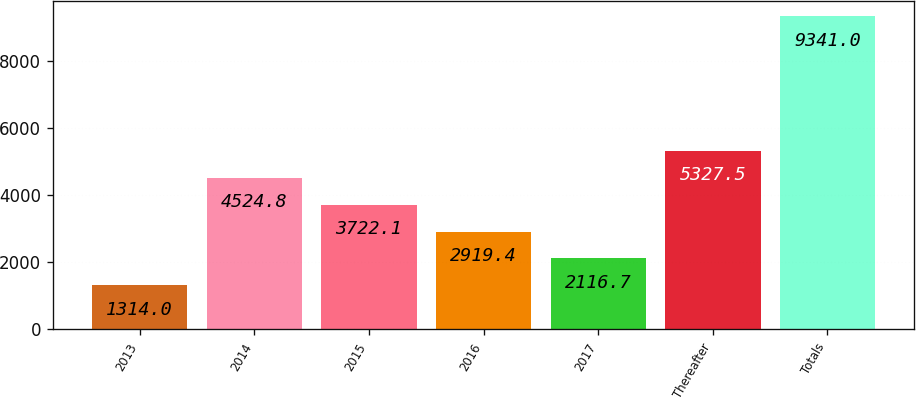<chart> <loc_0><loc_0><loc_500><loc_500><bar_chart><fcel>2013<fcel>2014<fcel>2015<fcel>2016<fcel>2017<fcel>Thereafter<fcel>Totals<nl><fcel>1314<fcel>4524.8<fcel>3722.1<fcel>2919.4<fcel>2116.7<fcel>5327.5<fcel>9341<nl></chart> 